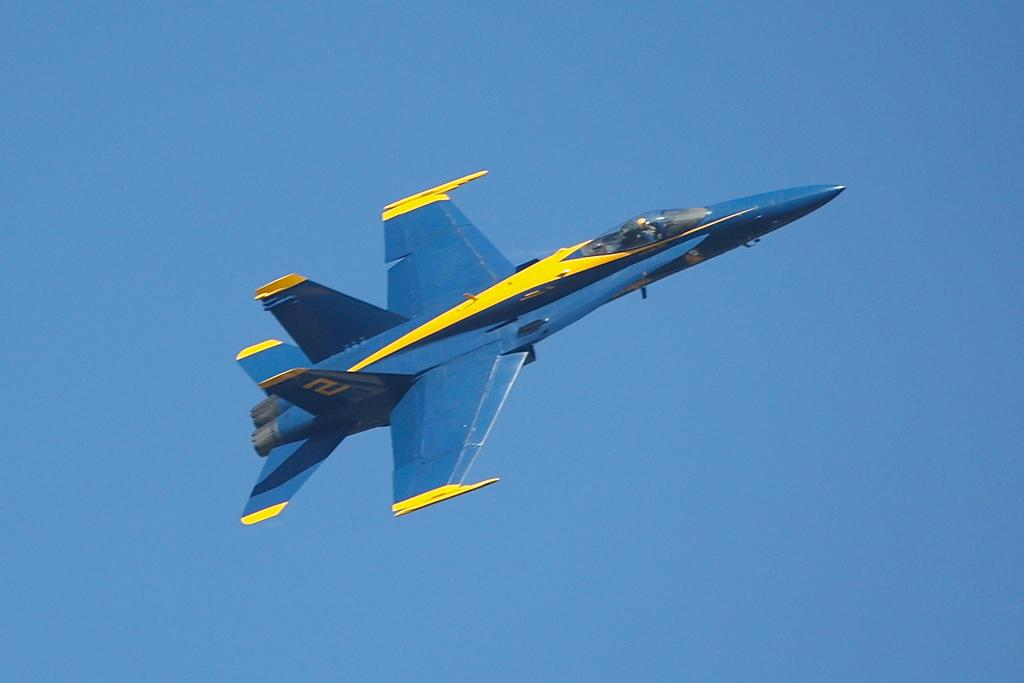What is the main subject of the image? The main subject of the image is an airplane. What is the airplane doing in the image? The airplane is flying in the image. What can be seen in the background of the image? The sky is visible in the background of the image. What is the color of the sky in the image? The sky is blue in color in the image. Can you see a horn on the airplane in the image? No, there is no horn present on the airplane in the image. 